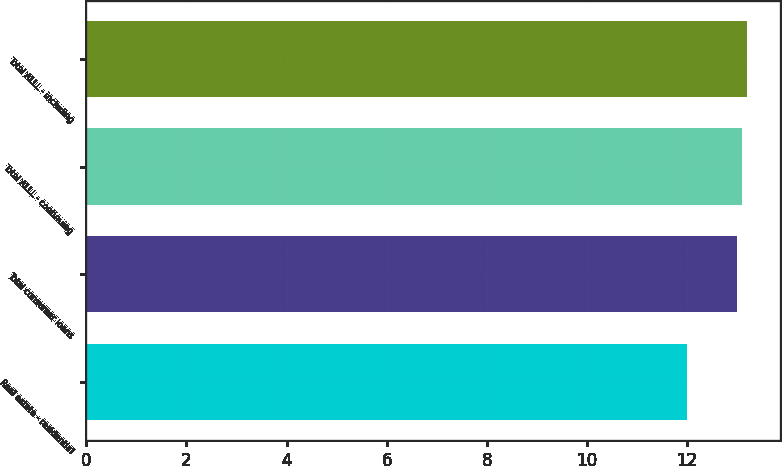Convert chart. <chart><loc_0><loc_0><loc_500><loc_500><bar_chart><fcel>Real estate - residential<fcel>Total consumer loans<fcel>Total ALLL - continuing<fcel>Total ALLL - including<nl><fcel>12<fcel>13<fcel>13.1<fcel>13.2<nl></chart> 